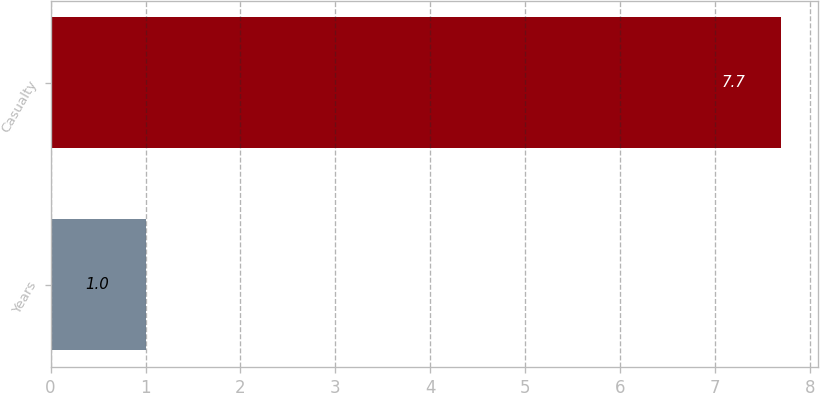<chart> <loc_0><loc_0><loc_500><loc_500><bar_chart><fcel>Years<fcel>Casualty<nl><fcel>1<fcel>7.7<nl></chart> 